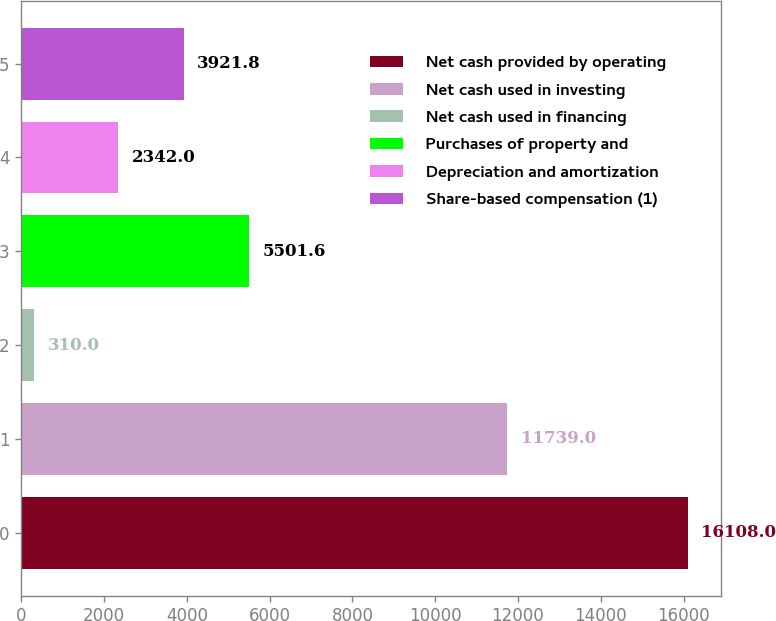<chart> <loc_0><loc_0><loc_500><loc_500><bar_chart><fcel>Net cash provided by operating<fcel>Net cash used in investing<fcel>Net cash used in financing<fcel>Purchases of property and<fcel>Depreciation and amortization<fcel>Share-based compensation (1)<nl><fcel>16108<fcel>11739<fcel>310<fcel>5501.6<fcel>2342<fcel>3921.8<nl></chart> 